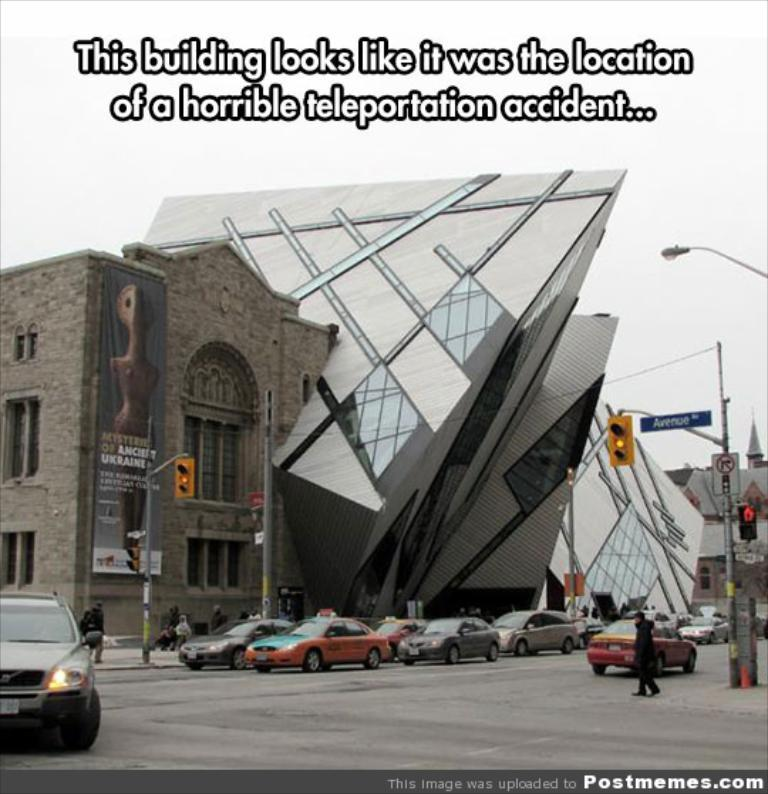What is the main subject of the image? The main subject of the image is vehicles. What are the vehicles doing in the image? The vehicles are moving on a road. Are there any traffic control devices in the image? Yes, there are traffic signals in the image. What can be seen in the background of the image? There are buildings in the background of the image. Where is the grandmother sitting in the image? There is no grandmother present in the image. What type of hook can be seen on the vehicles in the image? There are no hooks visible on the vehicles in the image. 